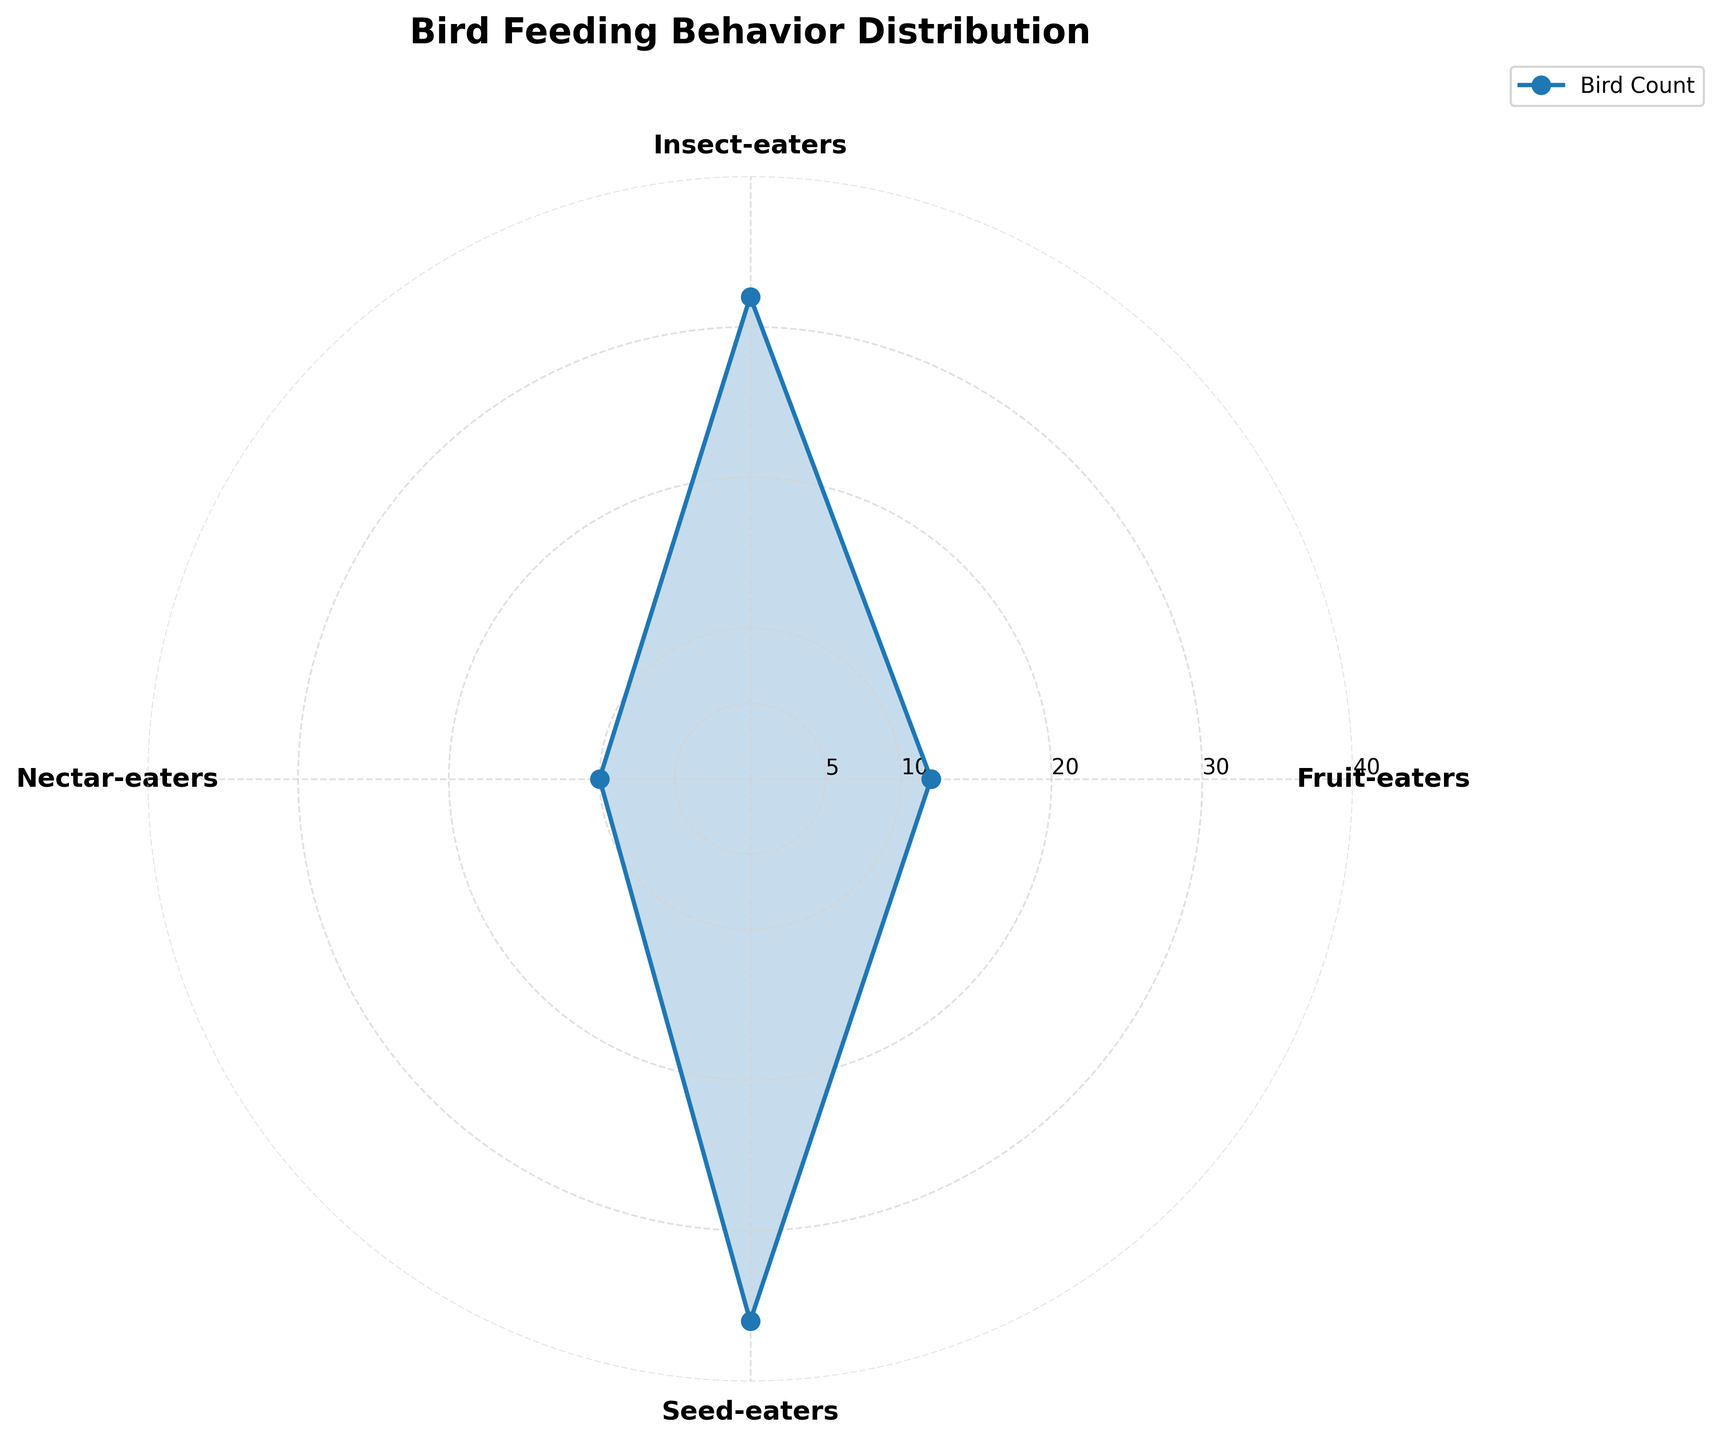What is the title of the figure? The title is typically displayed at the top of the plot and provides a summary of the depicted data. In this case, the title helps us understand the main subject of the chart, which refers to bird feeding behavior distribution.
Answer: Bird Feeding Behavior Distribution How many feeding behavior categories are represented in the chart? To determine this, count the distinct categories on the chart. Each category is represented by a segment with a corresponding label on the polar plot.
Answer: 4 Which feeding behavior category has the highest bird count? Look for the segment with the highest value along the radial axis. This segment will extend the furthest from the center of the plot.
Answer: Seed-eaters How many birds were observed in the Insect-eaters category? Identify the segment labeled "Insect-eaters" and read the value at the corresponding radial position. This value is the total count of birds in the category.
Answer: 32 What is the combined bird count of Fruit-eaters and Nectar-eaters? Sum the counts of the "Fruit-eaters" and "Nectar-eaters" segments. This can be derived by reading the values from the plot and adding them together.
Answer: 22 Which category has fewer birds, Nectar-eaters or Fruit-eaters? Compare the values of the "Nectar-eaters" and "Fruit-eaters" segments. The category with the smaller value has fewer birds.
Answer: Nectar-eaters What is the radial value increment on the plot's grid? The radial grid ticks indicate the increments, which help in estimating the values represented by the segments. Observing the spacing between tick marks provides this information.
Answer: 5 What is the difference in the bird count between Seed-eaters and Insect-eaters? Find the values for the "Seed-eaters" and "Insect-eaters" segments and subtract the count of the "Insect-eaters" from the count of the "Seed-eaters" to get the difference.
Answer: 10 If a new category "Omnivores" was added with a count of 20 birds, where would it fall on the plot in comparison to the existing categories? Based on the values from the current plot, compare the new count of 20 for "Omnivores" with the radial values of the four existing categories to determine its relative position.
Answer: Between Insect-eaters and Seed-eaters What proportion of the total bird count does the Seed-eaters category represent? First, sum the counts of all categories. Then, divide the count of the Seed-eaters by this total count to get the proportion.
Answer: 36% 